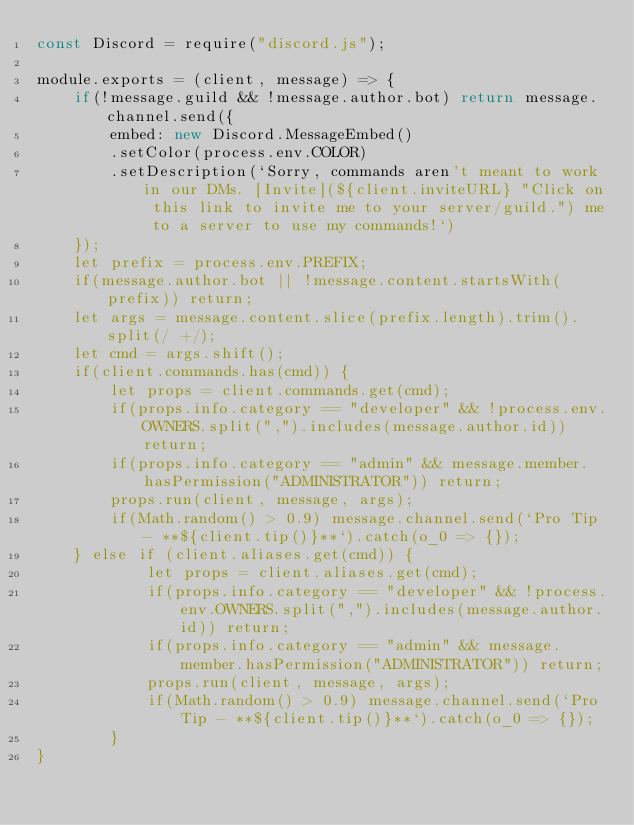<code> <loc_0><loc_0><loc_500><loc_500><_JavaScript_>const Discord = require("discord.js");

module.exports = (client, message) => {
    if(!message.guild && !message.author.bot) return message.channel.send({
        embed: new Discord.MessageEmbed()
        .setColor(process.env.COLOR)
        .setDescription(`Sorry, commands aren't meant to work in our DMs. [Invite](${client.inviteURL} "Click on this link to invite me to your server/guild.") me to a server to use my commands!`)
    });
    let prefix = process.env.PREFIX;
    if(message.author.bot || !message.content.startsWith(prefix)) return;
    let args = message.content.slice(prefix.length).trim().split(/ +/);
    let cmd = args.shift();
    if(client.commands.has(cmd)) {
        let props = client.commands.get(cmd);
        if(props.info.category == "developer" && !process.env.OWNERS.split(",").includes(message.author.id)) return;
        if(props.info.category == "admin" && message.member.hasPermission("ADMINISTRATOR")) return;
        props.run(client, message, args);
        if(Math.random() > 0.9) message.channel.send(`Pro Tip - **${client.tip()}**`).catch(o_0 => {});
    } else if (client.aliases.get(cmd)) {
            let props = client.aliases.get(cmd);
            if(props.info.category == "developer" && !process.env.OWNERS.split(",").includes(message.author.id)) return;
            if(props.info.category == "admin" && message.member.hasPermission("ADMINISTRATOR")) return;
            props.run(client, message, args);
            if(Math.random() > 0.9) message.channel.send(`Pro Tip - **${client.tip()}**`).catch(o_0 => {});
        }
}</code> 